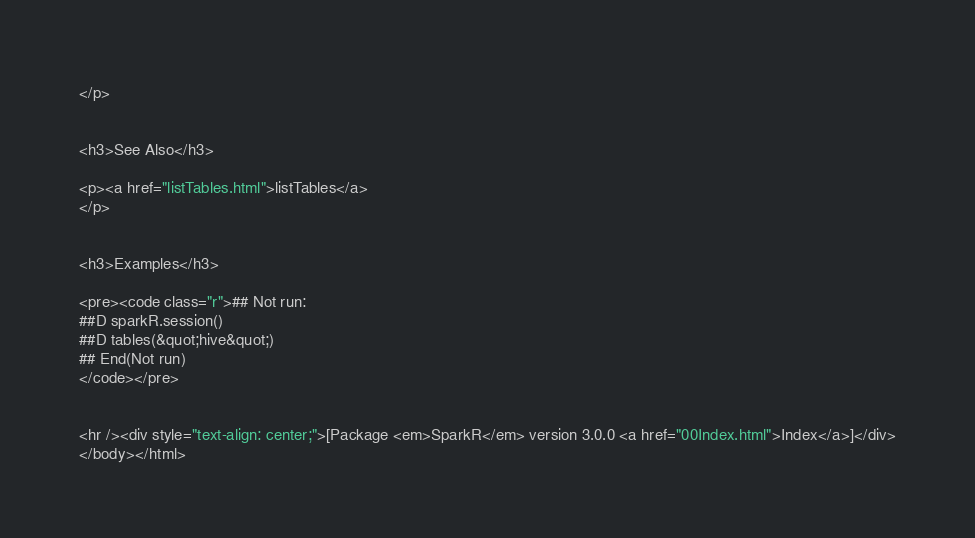<code> <loc_0><loc_0><loc_500><loc_500><_HTML_></p>


<h3>See Also</h3>

<p><a href="listTables.html">listTables</a>
</p>


<h3>Examples</h3>

<pre><code class="r">## Not run: 
##D sparkR.session()
##D tables(&quot;hive&quot;)
## End(Not run)
</code></pre>


<hr /><div style="text-align: center;">[Package <em>SparkR</em> version 3.0.0 <a href="00Index.html">Index</a>]</div>
</body></html>
</code> 